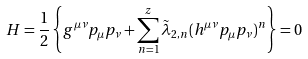<formula> <loc_0><loc_0><loc_500><loc_500>H = \frac { 1 } { 2 } \left \{ g ^ { \mu \nu } p _ { \mu } p _ { \nu } + \sum _ { n = 1 } ^ { z } \tilde { \lambda } _ { 2 , n } ( h ^ { \mu \nu } p _ { \mu } p _ { \nu } ) ^ { n } \right \} = 0</formula> 